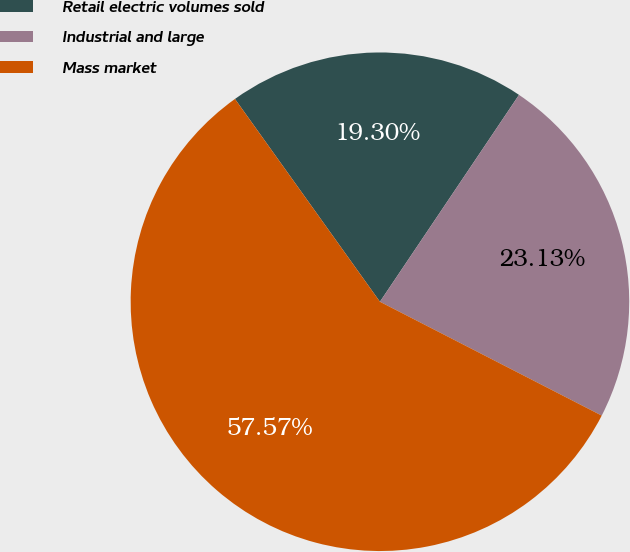Convert chart. <chart><loc_0><loc_0><loc_500><loc_500><pie_chart><fcel>Retail electric volumes sold<fcel>Industrial and large<fcel>Mass market<nl><fcel>19.3%<fcel>23.13%<fcel>57.58%<nl></chart> 